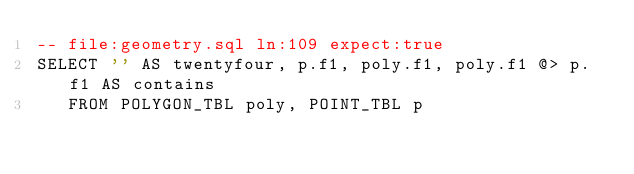<code> <loc_0><loc_0><loc_500><loc_500><_SQL_>-- file:geometry.sql ln:109 expect:true
SELECT '' AS twentyfour, p.f1, poly.f1, poly.f1 @> p.f1 AS contains
   FROM POLYGON_TBL poly, POINT_TBL p
</code> 